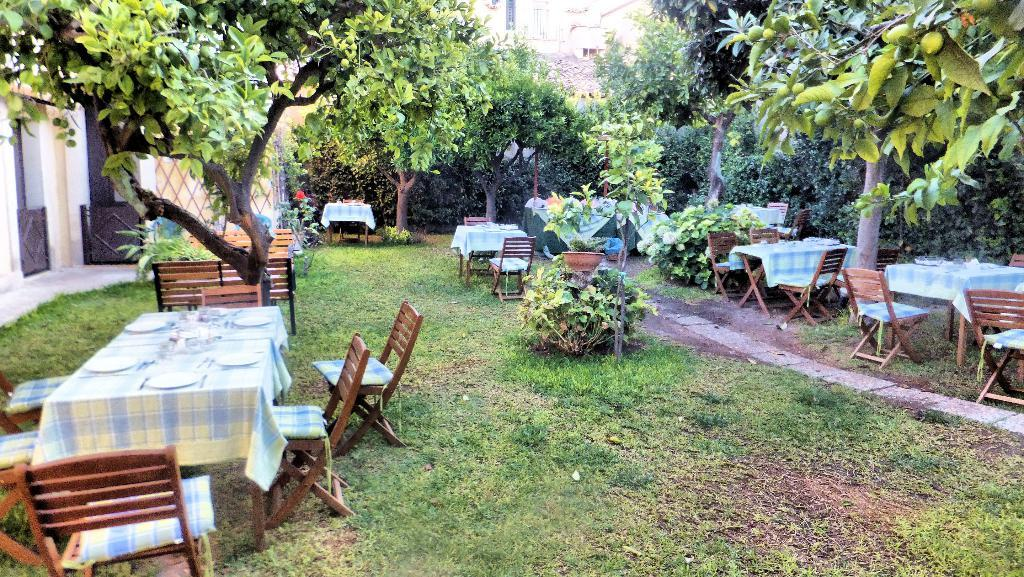How many tables can be seen in the image? There are multiple tables in the image. What other furniture is present in the image? There are multiple chairs in the image. What type of vegetation is visible in the image? There are many trees visible in the image. What type of ground surface is at the bottom of the image? There is grass at the bottom of the image. What type of iron can be seen on the sofa in the image? There is no sofa or iron present in the image. What color is the powder on the table in the image? There is no powder present in the image. 